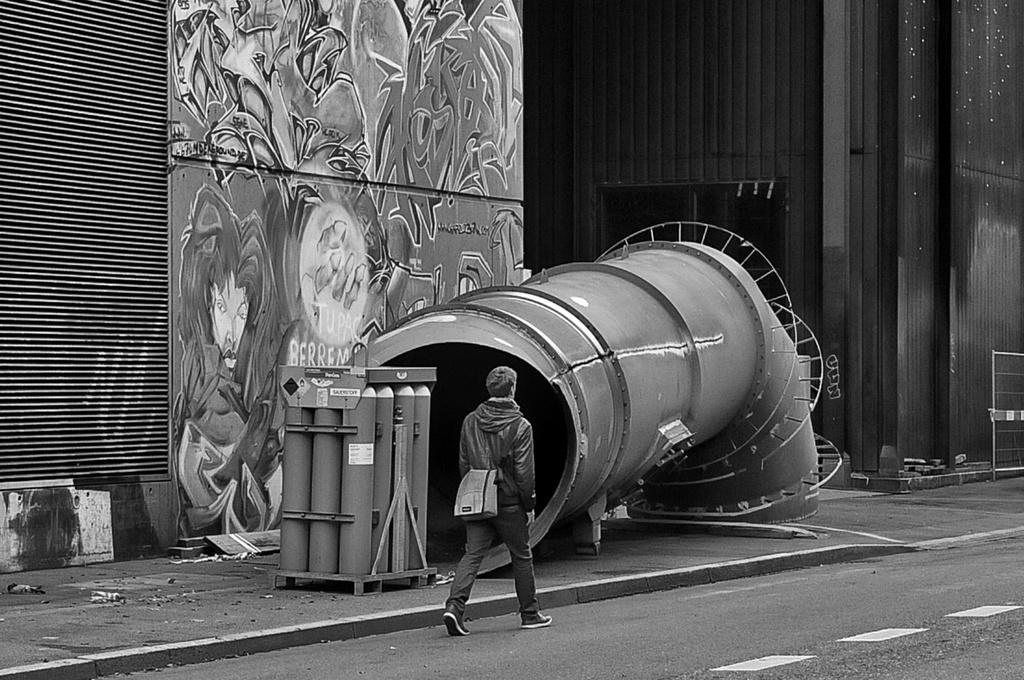How would you summarize this image in a sentence or two? This is a black and white image. In this image we can see a man wearing a bag is walking on the road. Near to the road there is a sidewalk. On that there is a pipe. Also there is an another object with cylinders. And there is a wall. On the wall there is a graffiti on the board. 